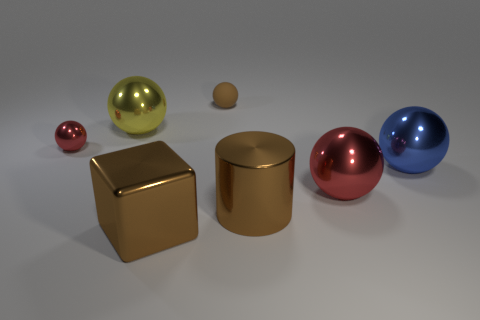There is a red object that is right of the yellow object; is its shape the same as the large brown thing left of the small brown rubber object?
Offer a very short reply. No. Are there an equal number of tiny brown matte things that are to the left of the small matte object and small spheres?
Provide a short and direct response. No. What is the color of the other rubber thing that is the same shape as the blue thing?
Keep it short and to the point. Brown. Does the brown object that is on the left side of the matte object have the same material as the cylinder?
Give a very brief answer. Yes. How many small things are yellow cubes or metal cylinders?
Ensure brevity in your answer.  0. What is the size of the yellow sphere?
Your answer should be compact. Large. Do the brown block and the red metallic sphere that is in front of the small red metallic sphere have the same size?
Make the answer very short. Yes. What number of cyan objects are either small shiny spheres or big cylinders?
Provide a succinct answer. 0. How many yellow objects are there?
Ensure brevity in your answer.  1. There is a metal block in front of the rubber object; what size is it?
Give a very brief answer. Large. 